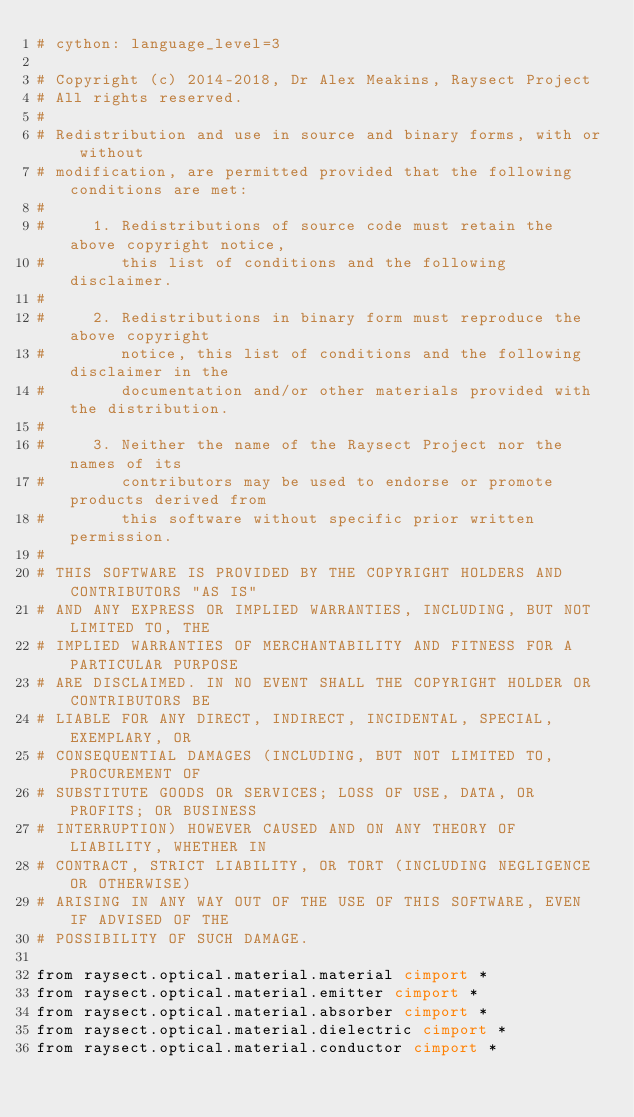<code> <loc_0><loc_0><loc_500><loc_500><_Cython_># cython: language_level=3

# Copyright (c) 2014-2018, Dr Alex Meakins, Raysect Project
# All rights reserved.
#
# Redistribution and use in source and binary forms, with or without
# modification, are permitted provided that the following conditions are met:
#
#     1. Redistributions of source code must retain the above copyright notice,
#        this list of conditions and the following disclaimer.
#
#     2. Redistributions in binary form must reproduce the above copyright
#        notice, this list of conditions and the following disclaimer in the
#        documentation and/or other materials provided with the distribution.
#
#     3. Neither the name of the Raysect Project nor the names of its
#        contributors may be used to endorse or promote products derived from
#        this software without specific prior written permission.
#
# THIS SOFTWARE IS PROVIDED BY THE COPYRIGHT HOLDERS AND CONTRIBUTORS "AS IS"
# AND ANY EXPRESS OR IMPLIED WARRANTIES, INCLUDING, BUT NOT LIMITED TO, THE
# IMPLIED WARRANTIES OF MERCHANTABILITY AND FITNESS FOR A PARTICULAR PURPOSE
# ARE DISCLAIMED. IN NO EVENT SHALL THE COPYRIGHT HOLDER OR CONTRIBUTORS BE
# LIABLE FOR ANY DIRECT, INDIRECT, INCIDENTAL, SPECIAL, EXEMPLARY, OR
# CONSEQUENTIAL DAMAGES (INCLUDING, BUT NOT LIMITED TO, PROCUREMENT OF
# SUBSTITUTE GOODS OR SERVICES; LOSS OF USE, DATA, OR PROFITS; OR BUSINESS
# INTERRUPTION) HOWEVER CAUSED AND ON ANY THEORY OF LIABILITY, WHETHER IN
# CONTRACT, STRICT LIABILITY, OR TORT (INCLUDING NEGLIGENCE OR OTHERWISE)
# ARISING IN ANY WAY OUT OF THE USE OF THIS SOFTWARE, EVEN IF ADVISED OF THE
# POSSIBILITY OF SUCH DAMAGE.

from raysect.optical.material.material cimport *
from raysect.optical.material.emitter cimport *
from raysect.optical.material.absorber cimport *
from raysect.optical.material.dielectric cimport *
from raysect.optical.material.conductor cimport *
</code> 